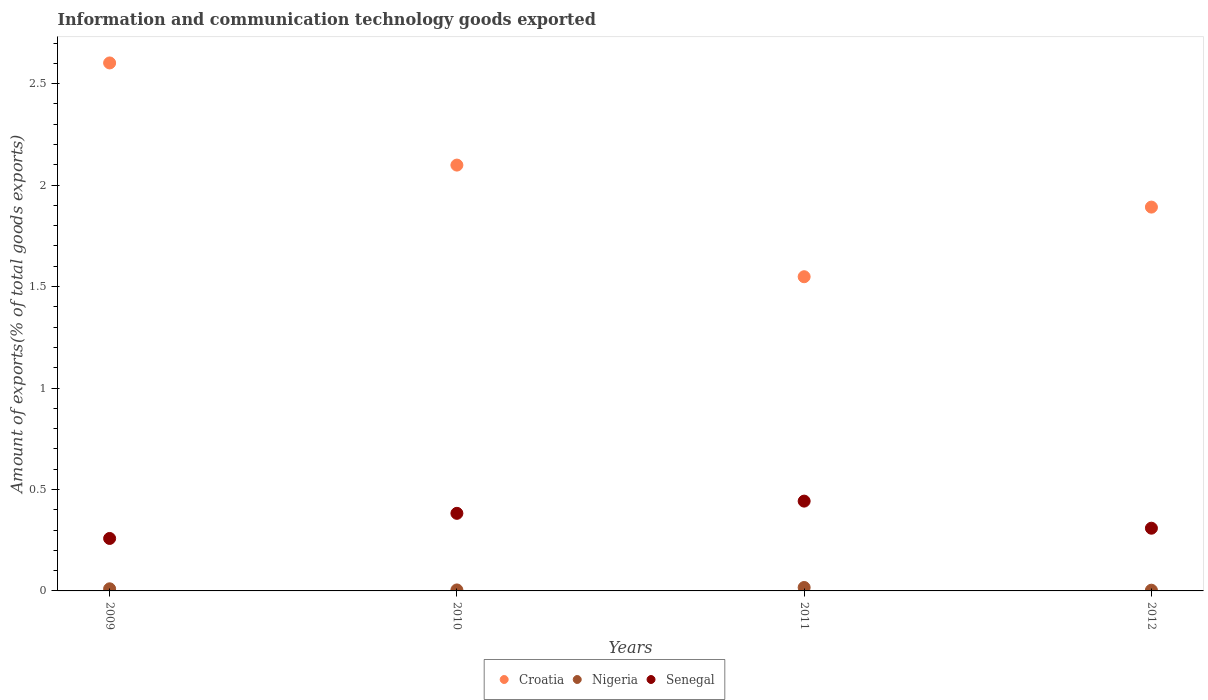How many different coloured dotlines are there?
Make the answer very short. 3. Is the number of dotlines equal to the number of legend labels?
Keep it short and to the point. Yes. What is the amount of goods exported in Croatia in 2009?
Offer a very short reply. 2.6. Across all years, what is the maximum amount of goods exported in Nigeria?
Your response must be concise. 0.02. Across all years, what is the minimum amount of goods exported in Nigeria?
Offer a terse response. 0. In which year was the amount of goods exported in Senegal maximum?
Ensure brevity in your answer.  2011. What is the total amount of goods exported in Croatia in the graph?
Provide a short and direct response. 8.14. What is the difference between the amount of goods exported in Croatia in 2010 and that in 2012?
Give a very brief answer. 0.21. What is the difference between the amount of goods exported in Nigeria in 2011 and the amount of goods exported in Croatia in 2012?
Your answer should be compact. -1.87. What is the average amount of goods exported in Senegal per year?
Offer a terse response. 0.35. In the year 2011, what is the difference between the amount of goods exported in Nigeria and amount of goods exported in Senegal?
Your answer should be compact. -0.43. What is the ratio of the amount of goods exported in Senegal in 2009 to that in 2010?
Provide a succinct answer. 0.68. Is the amount of goods exported in Croatia in 2010 less than that in 2011?
Provide a short and direct response. No. What is the difference between the highest and the second highest amount of goods exported in Croatia?
Provide a succinct answer. 0.5. What is the difference between the highest and the lowest amount of goods exported in Nigeria?
Provide a short and direct response. 0.01. Is it the case that in every year, the sum of the amount of goods exported in Nigeria and amount of goods exported in Senegal  is greater than the amount of goods exported in Croatia?
Your answer should be compact. No. Is the amount of goods exported in Croatia strictly greater than the amount of goods exported in Senegal over the years?
Offer a very short reply. Yes. How many dotlines are there?
Offer a terse response. 3. Does the graph contain grids?
Provide a succinct answer. No. Where does the legend appear in the graph?
Provide a succinct answer. Bottom center. How many legend labels are there?
Offer a terse response. 3. How are the legend labels stacked?
Give a very brief answer. Horizontal. What is the title of the graph?
Your answer should be very brief. Information and communication technology goods exported. What is the label or title of the Y-axis?
Ensure brevity in your answer.  Amount of exports(% of total goods exports). What is the Amount of exports(% of total goods exports) of Croatia in 2009?
Provide a short and direct response. 2.6. What is the Amount of exports(% of total goods exports) in Nigeria in 2009?
Your response must be concise. 0.01. What is the Amount of exports(% of total goods exports) of Senegal in 2009?
Your response must be concise. 0.26. What is the Amount of exports(% of total goods exports) in Croatia in 2010?
Your answer should be very brief. 2.1. What is the Amount of exports(% of total goods exports) in Nigeria in 2010?
Your answer should be compact. 0. What is the Amount of exports(% of total goods exports) in Senegal in 2010?
Provide a short and direct response. 0.38. What is the Amount of exports(% of total goods exports) of Croatia in 2011?
Give a very brief answer. 1.55. What is the Amount of exports(% of total goods exports) in Nigeria in 2011?
Your answer should be compact. 0.02. What is the Amount of exports(% of total goods exports) in Senegal in 2011?
Offer a terse response. 0.44. What is the Amount of exports(% of total goods exports) of Croatia in 2012?
Your answer should be very brief. 1.89. What is the Amount of exports(% of total goods exports) in Nigeria in 2012?
Offer a terse response. 0. What is the Amount of exports(% of total goods exports) in Senegal in 2012?
Provide a succinct answer. 0.31. Across all years, what is the maximum Amount of exports(% of total goods exports) in Croatia?
Offer a very short reply. 2.6. Across all years, what is the maximum Amount of exports(% of total goods exports) of Nigeria?
Offer a terse response. 0.02. Across all years, what is the maximum Amount of exports(% of total goods exports) in Senegal?
Offer a terse response. 0.44. Across all years, what is the minimum Amount of exports(% of total goods exports) in Croatia?
Provide a short and direct response. 1.55. Across all years, what is the minimum Amount of exports(% of total goods exports) in Nigeria?
Your response must be concise. 0. Across all years, what is the minimum Amount of exports(% of total goods exports) of Senegal?
Offer a terse response. 0.26. What is the total Amount of exports(% of total goods exports) of Croatia in the graph?
Give a very brief answer. 8.14. What is the total Amount of exports(% of total goods exports) in Nigeria in the graph?
Offer a terse response. 0.04. What is the total Amount of exports(% of total goods exports) in Senegal in the graph?
Ensure brevity in your answer.  1.39. What is the difference between the Amount of exports(% of total goods exports) in Croatia in 2009 and that in 2010?
Keep it short and to the point. 0.5. What is the difference between the Amount of exports(% of total goods exports) in Nigeria in 2009 and that in 2010?
Offer a very short reply. 0.01. What is the difference between the Amount of exports(% of total goods exports) in Senegal in 2009 and that in 2010?
Provide a short and direct response. -0.12. What is the difference between the Amount of exports(% of total goods exports) of Croatia in 2009 and that in 2011?
Provide a succinct answer. 1.05. What is the difference between the Amount of exports(% of total goods exports) of Nigeria in 2009 and that in 2011?
Give a very brief answer. -0.01. What is the difference between the Amount of exports(% of total goods exports) in Senegal in 2009 and that in 2011?
Your answer should be very brief. -0.18. What is the difference between the Amount of exports(% of total goods exports) of Croatia in 2009 and that in 2012?
Give a very brief answer. 0.71. What is the difference between the Amount of exports(% of total goods exports) in Nigeria in 2009 and that in 2012?
Provide a short and direct response. 0.01. What is the difference between the Amount of exports(% of total goods exports) of Senegal in 2009 and that in 2012?
Offer a terse response. -0.05. What is the difference between the Amount of exports(% of total goods exports) of Croatia in 2010 and that in 2011?
Provide a succinct answer. 0.55. What is the difference between the Amount of exports(% of total goods exports) in Nigeria in 2010 and that in 2011?
Keep it short and to the point. -0.01. What is the difference between the Amount of exports(% of total goods exports) in Senegal in 2010 and that in 2011?
Offer a terse response. -0.06. What is the difference between the Amount of exports(% of total goods exports) in Croatia in 2010 and that in 2012?
Keep it short and to the point. 0.21. What is the difference between the Amount of exports(% of total goods exports) of Nigeria in 2010 and that in 2012?
Your answer should be compact. 0. What is the difference between the Amount of exports(% of total goods exports) in Senegal in 2010 and that in 2012?
Give a very brief answer. 0.07. What is the difference between the Amount of exports(% of total goods exports) of Croatia in 2011 and that in 2012?
Offer a terse response. -0.34. What is the difference between the Amount of exports(% of total goods exports) of Nigeria in 2011 and that in 2012?
Offer a very short reply. 0.01. What is the difference between the Amount of exports(% of total goods exports) in Senegal in 2011 and that in 2012?
Your answer should be very brief. 0.13. What is the difference between the Amount of exports(% of total goods exports) of Croatia in 2009 and the Amount of exports(% of total goods exports) of Nigeria in 2010?
Offer a terse response. 2.6. What is the difference between the Amount of exports(% of total goods exports) of Croatia in 2009 and the Amount of exports(% of total goods exports) of Senegal in 2010?
Keep it short and to the point. 2.22. What is the difference between the Amount of exports(% of total goods exports) in Nigeria in 2009 and the Amount of exports(% of total goods exports) in Senegal in 2010?
Keep it short and to the point. -0.37. What is the difference between the Amount of exports(% of total goods exports) of Croatia in 2009 and the Amount of exports(% of total goods exports) of Nigeria in 2011?
Your answer should be very brief. 2.59. What is the difference between the Amount of exports(% of total goods exports) of Croatia in 2009 and the Amount of exports(% of total goods exports) of Senegal in 2011?
Ensure brevity in your answer.  2.16. What is the difference between the Amount of exports(% of total goods exports) of Nigeria in 2009 and the Amount of exports(% of total goods exports) of Senegal in 2011?
Your answer should be compact. -0.43. What is the difference between the Amount of exports(% of total goods exports) in Croatia in 2009 and the Amount of exports(% of total goods exports) in Nigeria in 2012?
Offer a very short reply. 2.6. What is the difference between the Amount of exports(% of total goods exports) of Croatia in 2009 and the Amount of exports(% of total goods exports) of Senegal in 2012?
Ensure brevity in your answer.  2.29. What is the difference between the Amount of exports(% of total goods exports) in Nigeria in 2009 and the Amount of exports(% of total goods exports) in Senegal in 2012?
Provide a succinct answer. -0.3. What is the difference between the Amount of exports(% of total goods exports) of Croatia in 2010 and the Amount of exports(% of total goods exports) of Nigeria in 2011?
Your answer should be very brief. 2.08. What is the difference between the Amount of exports(% of total goods exports) in Croatia in 2010 and the Amount of exports(% of total goods exports) in Senegal in 2011?
Offer a very short reply. 1.66. What is the difference between the Amount of exports(% of total goods exports) in Nigeria in 2010 and the Amount of exports(% of total goods exports) in Senegal in 2011?
Your answer should be compact. -0.44. What is the difference between the Amount of exports(% of total goods exports) in Croatia in 2010 and the Amount of exports(% of total goods exports) in Nigeria in 2012?
Your answer should be very brief. 2.1. What is the difference between the Amount of exports(% of total goods exports) in Croatia in 2010 and the Amount of exports(% of total goods exports) in Senegal in 2012?
Offer a very short reply. 1.79. What is the difference between the Amount of exports(% of total goods exports) in Nigeria in 2010 and the Amount of exports(% of total goods exports) in Senegal in 2012?
Make the answer very short. -0.3. What is the difference between the Amount of exports(% of total goods exports) in Croatia in 2011 and the Amount of exports(% of total goods exports) in Nigeria in 2012?
Provide a short and direct response. 1.54. What is the difference between the Amount of exports(% of total goods exports) of Croatia in 2011 and the Amount of exports(% of total goods exports) of Senegal in 2012?
Your answer should be compact. 1.24. What is the difference between the Amount of exports(% of total goods exports) of Nigeria in 2011 and the Amount of exports(% of total goods exports) of Senegal in 2012?
Keep it short and to the point. -0.29. What is the average Amount of exports(% of total goods exports) of Croatia per year?
Keep it short and to the point. 2.04. What is the average Amount of exports(% of total goods exports) of Nigeria per year?
Your response must be concise. 0.01. What is the average Amount of exports(% of total goods exports) of Senegal per year?
Your response must be concise. 0.35. In the year 2009, what is the difference between the Amount of exports(% of total goods exports) of Croatia and Amount of exports(% of total goods exports) of Nigeria?
Give a very brief answer. 2.59. In the year 2009, what is the difference between the Amount of exports(% of total goods exports) in Croatia and Amount of exports(% of total goods exports) in Senegal?
Give a very brief answer. 2.34. In the year 2009, what is the difference between the Amount of exports(% of total goods exports) in Nigeria and Amount of exports(% of total goods exports) in Senegal?
Offer a terse response. -0.25. In the year 2010, what is the difference between the Amount of exports(% of total goods exports) in Croatia and Amount of exports(% of total goods exports) in Nigeria?
Keep it short and to the point. 2.09. In the year 2010, what is the difference between the Amount of exports(% of total goods exports) of Croatia and Amount of exports(% of total goods exports) of Senegal?
Provide a succinct answer. 1.72. In the year 2010, what is the difference between the Amount of exports(% of total goods exports) of Nigeria and Amount of exports(% of total goods exports) of Senegal?
Your response must be concise. -0.38. In the year 2011, what is the difference between the Amount of exports(% of total goods exports) of Croatia and Amount of exports(% of total goods exports) of Nigeria?
Offer a very short reply. 1.53. In the year 2011, what is the difference between the Amount of exports(% of total goods exports) in Croatia and Amount of exports(% of total goods exports) in Senegal?
Give a very brief answer. 1.11. In the year 2011, what is the difference between the Amount of exports(% of total goods exports) in Nigeria and Amount of exports(% of total goods exports) in Senegal?
Offer a terse response. -0.43. In the year 2012, what is the difference between the Amount of exports(% of total goods exports) of Croatia and Amount of exports(% of total goods exports) of Nigeria?
Make the answer very short. 1.89. In the year 2012, what is the difference between the Amount of exports(% of total goods exports) of Croatia and Amount of exports(% of total goods exports) of Senegal?
Your answer should be compact. 1.58. In the year 2012, what is the difference between the Amount of exports(% of total goods exports) of Nigeria and Amount of exports(% of total goods exports) of Senegal?
Offer a very short reply. -0.31. What is the ratio of the Amount of exports(% of total goods exports) of Croatia in 2009 to that in 2010?
Make the answer very short. 1.24. What is the ratio of the Amount of exports(% of total goods exports) in Nigeria in 2009 to that in 2010?
Your answer should be compact. 2.18. What is the ratio of the Amount of exports(% of total goods exports) in Senegal in 2009 to that in 2010?
Your response must be concise. 0.68. What is the ratio of the Amount of exports(% of total goods exports) in Croatia in 2009 to that in 2011?
Provide a short and direct response. 1.68. What is the ratio of the Amount of exports(% of total goods exports) in Nigeria in 2009 to that in 2011?
Make the answer very short. 0.62. What is the ratio of the Amount of exports(% of total goods exports) in Senegal in 2009 to that in 2011?
Provide a short and direct response. 0.58. What is the ratio of the Amount of exports(% of total goods exports) in Croatia in 2009 to that in 2012?
Offer a terse response. 1.38. What is the ratio of the Amount of exports(% of total goods exports) in Nigeria in 2009 to that in 2012?
Offer a very short reply. 2.92. What is the ratio of the Amount of exports(% of total goods exports) in Senegal in 2009 to that in 2012?
Your answer should be very brief. 0.84. What is the ratio of the Amount of exports(% of total goods exports) of Croatia in 2010 to that in 2011?
Provide a short and direct response. 1.36. What is the ratio of the Amount of exports(% of total goods exports) in Nigeria in 2010 to that in 2011?
Provide a succinct answer. 0.28. What is the ratio of the Amount of exports(% of total goods exports) of Senegal in 2010 to that in 2011?
Your answer should be compact. 0.86. What is the ratio of the Amount of exports(% of total goods exports) of Croatia in 2010 to that in 2012?
Offer a terse response. 1.11. What is the ratio of the Amount of exports(% of total goods exports) in Nigeria in 2010 to that in 2012?
Give a very brief answer. 1.34. What is the ratio of the Amount of exports(% of total goods exports) in Senegal in 2010 to that in 2012?
Your answer should be very brief. 1.24. What is the ratio of the Amount of exports(% of total goods exports) in Croatia in 2011 to that in 2012?
Your response must be concise. 0.82. What is the ratio of the Amount of exports(% of total goods exports) in Nigeria in 2011 to that in 2012?
Make the answer very short. 4.71. What is the ratio of the Amount of exports(% of total goods exports) in Senegal in 2011 to that in 2012?
Your answer should be very brief. 1.43. What is the difference between the highest and the second highest Amount of exports(% of total goods exports) of Croatia?
Keep it short and to the point. 0.5. What is the difference between the highest and the second highest Amount of exports(% of total goods exports) of Nigeria?
Keep it short and to the point. 0.01. What is the difference between the highest and the second highest Amount of exports(% of total goods exports) in Senegal?
Keep it short and to the point. 0.06. What is the difference between the highest and the lowest Amount of exports(% of total goods exports) of Croatia?
Your response must be concise. 1.05. What is the difference between the highest and the lowest Amount of exports(% of total goods exports) of Nigeria?
Offer a very short reply. 0.01. What is the difference between the highest and the lowest Amount of exports(% of total goods exports) in Senegal?
Give a very brief answer. 0.18. 